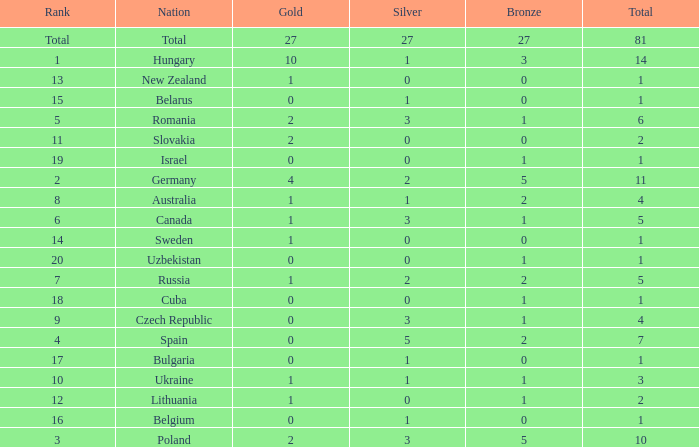How much Silver has a Rank of 1, and a Bronze smaller than 3? None. Would you be able to parse every entry in this table? {'header': ['Rank', 'Nation', 'Gold', 'Silver', 'Bronze', 'Total'], 'rows': [['Total', 'Total', '27', '27', '27', '81'], ['1', 'Hungary', '10', '1', '3', '14'], ['13', 'New Zealand', '1', '0', '0', '1'], ['15', 'Belarus', '0', '1', '0', '1'], ['5', 'Romania', '2', '3', '1', '6'], ['11', 'Slovakia', '2', '0', '0', '2'], ['19', 'Israel', '0', '0', '1', '1'], ['2', 'Germany', '4', '2', '5', '11'], ['8', 'Australia', '1', '1', '2', '4'], ['6', 'Canada', '1', '3', '1', '5'], ['14', 'Sweden', '1', '0', '0', '1'], ['20', 'Uzbekistan', '0', '0', '1', '1'], ['7', 'Russia', '1', '2', '2', '5'], ['18', 'Cuba', '0', '0', '1', '1'], ['9', 'Czech Republic', '0', '3', '1', '4'], ['4', 'Spain', '0', '5', '2', '7'], ['17', 'Bulgaria', '0', '1', '0', '1'], ['10', 'Ukraine', '1', '1', '1', '3'], ['12', 'Lithuania', '1', '0', '1', '2'], ['16', 'Belgium', '0', '1', '0', '1'], ['3', 'Poland', '2', '3', '5', '10']]} 